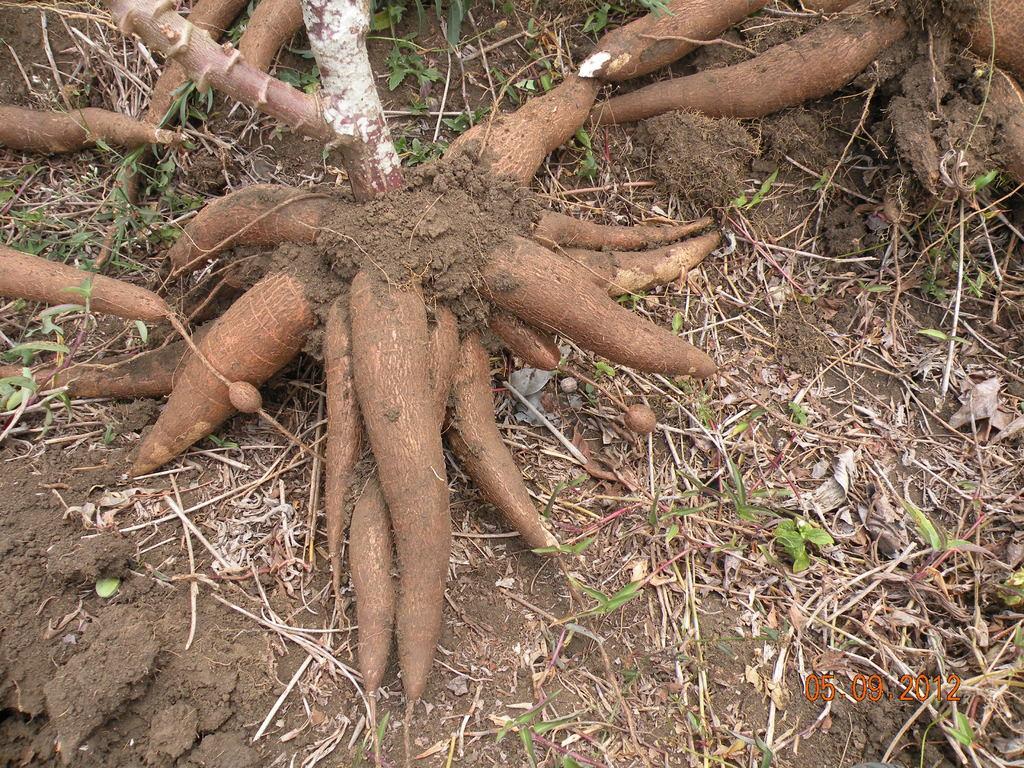In one or two sentences, can you explain what this image depicts? In this image I can see the tree roots which are in brown color. I can see the grass on the ground. 